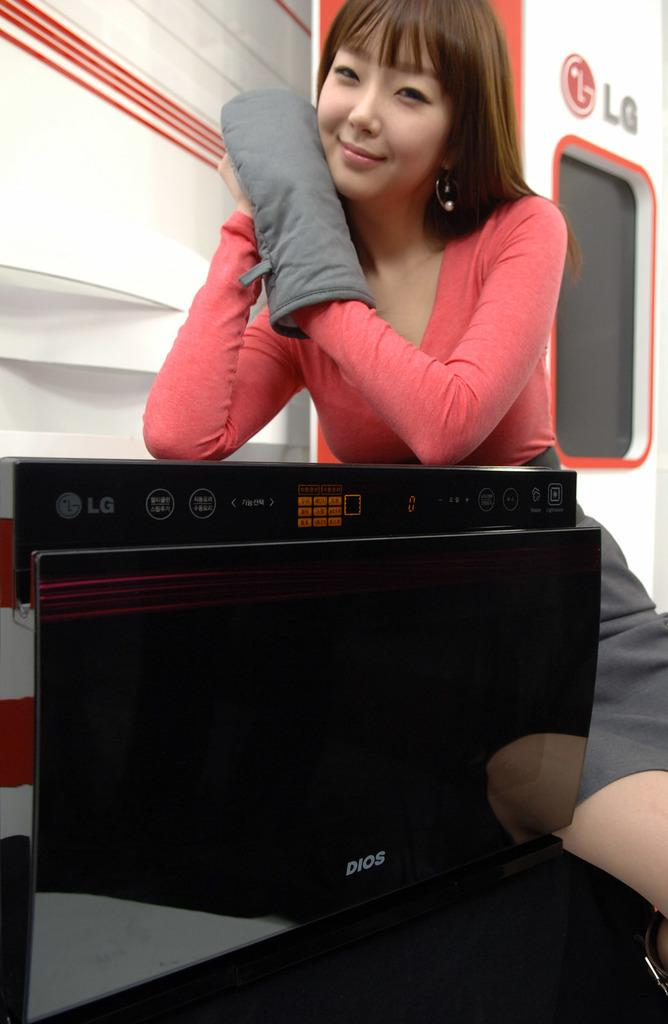<image>
Present a compact description of the photo's key features. A woman is posing with a kitchen mitten with an LG sign at the background. 